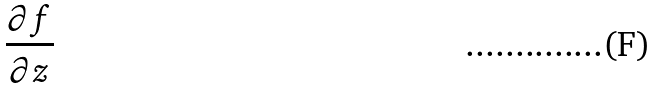<formula> <loc_0><loc_0><loc_500><loc_500>\frac { \partial f } { \partial z }</formula> 